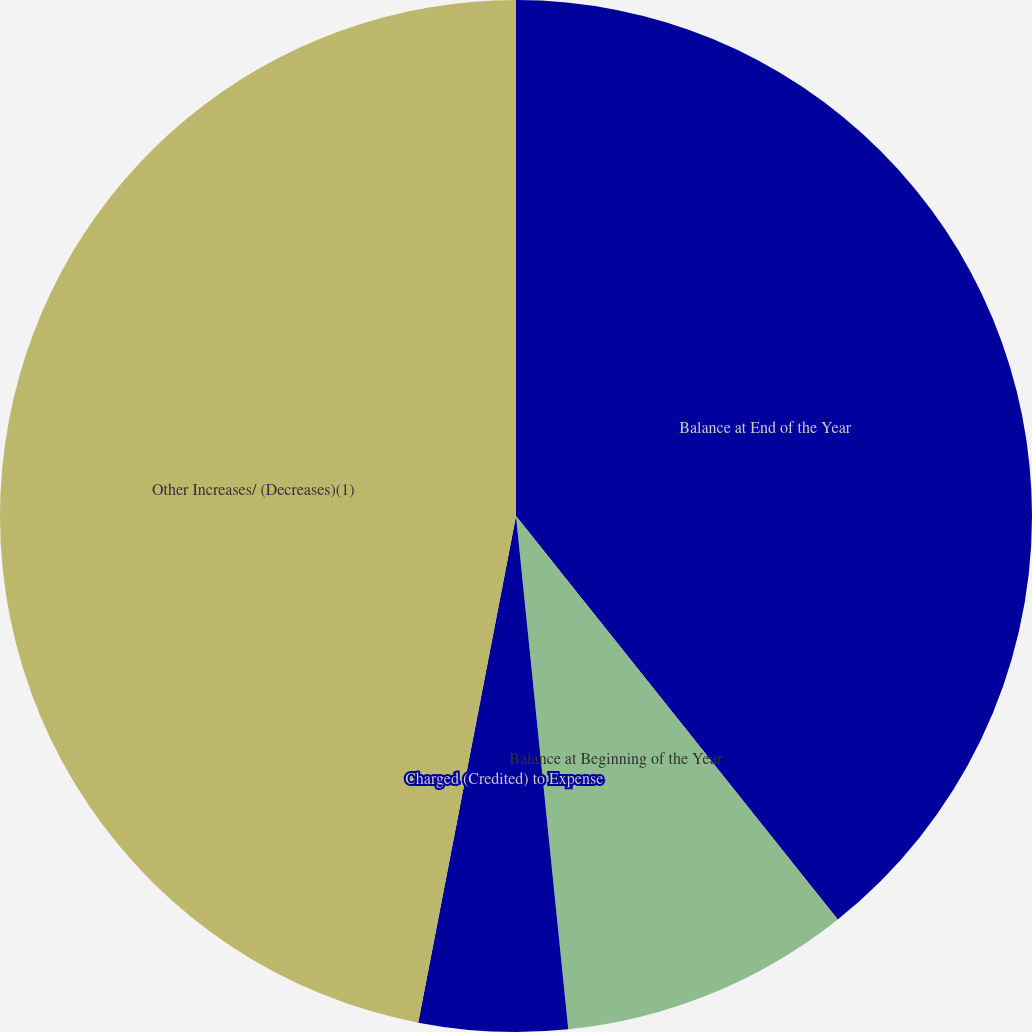Convert chart. <chart><loc_0><loc_0><loc_500><loc_500><pie_chart><fcel>Balance at End of the Year<fcel>Balance at Beginning of the Year<fcel>Charged (Credited) to Expense<fcel>Other Increases/ (Decreases)(1)<nl><fcel>39.28%<fcel>9.1%<fcel>4.65%<fcel>46.96%<nl></chart> 